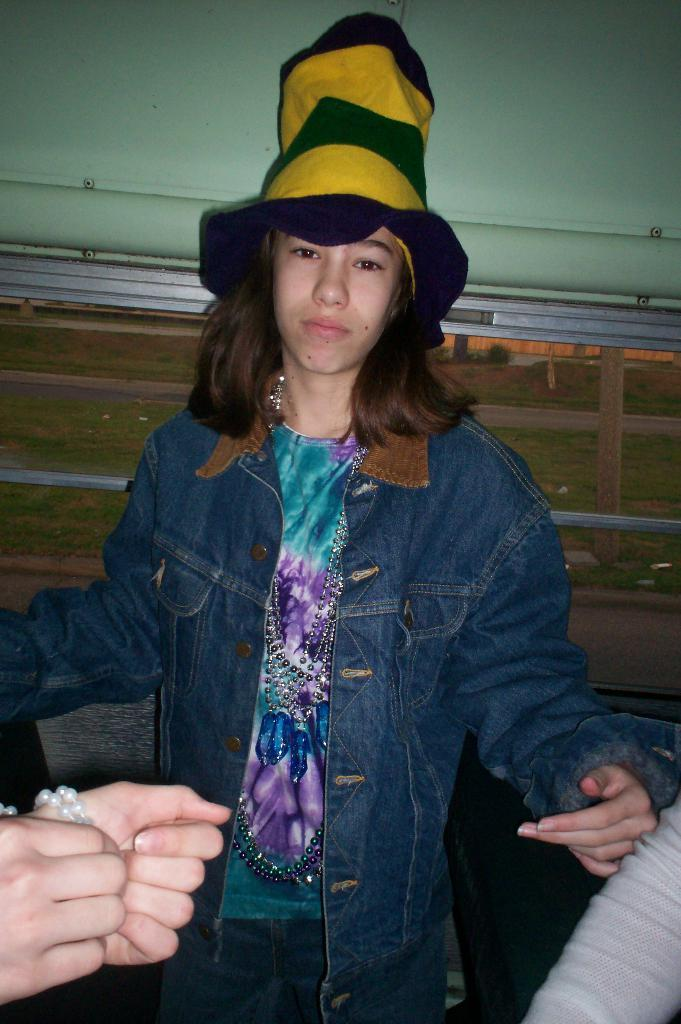Who or what is the main subject in the image? There is a person in the image. What is the person wearing? The person is wearing a jacket. What is the person doing in the image? The person is standing. What else can be seen in the image besides the person? There are other objects in the background of the image. Can you describe any specific body part of the person that is visible? A person's hand is visible in the image. What is the governor's reaction to the smoke in the image? There is no governor or smoke present in the image. 